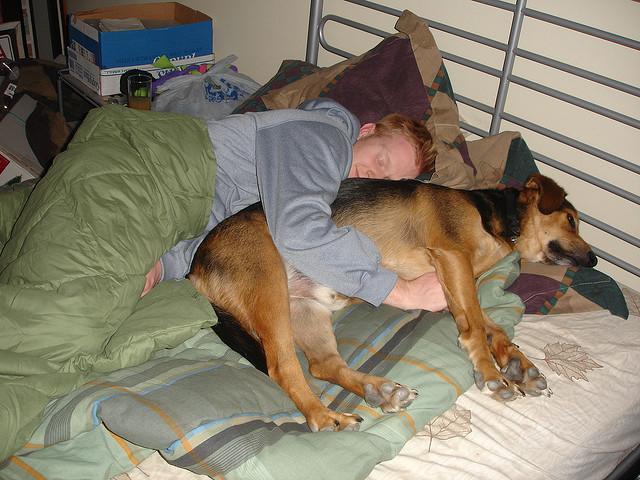What is the owner giving his dog?
Indicate the correct response by choosing from the four available options to answer the question.
Options: Time out, food, hug, medication. Hug. 